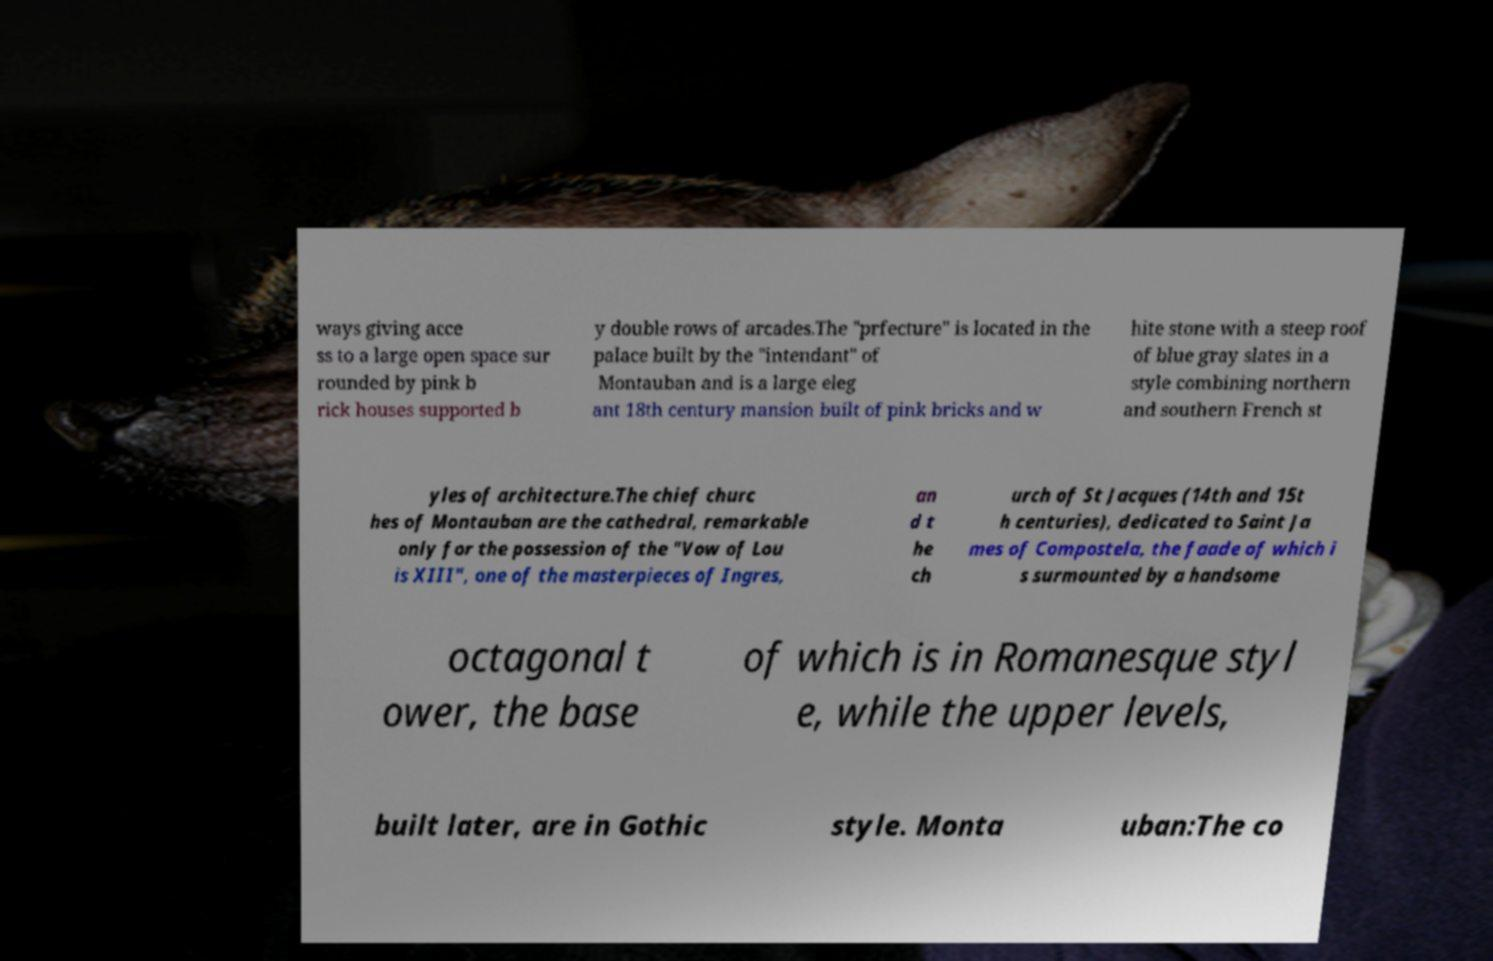I need the written content from this picture converted into text. Can you do that? ways giving acce ss to a large open space sur rounded by pink b rick houses supported b y double rows of arcades.The "prfecture" is located in the palace built by the "intendant" of Montauban and is a large eleg ant 18th century mansion built of pink bricks and w hite stone with a steep roof of blue gray slates in a style combining northern and southern French st yles of architecture.The chief churc hes of Montauban are the cathedral, remarkable only for the possession of the "Vow of Lou is XIII", one of the masterpieces of Ingres, an d t he ch urch of St Jacques (14th and 15t h centuries), dedicated to Saint Ja mes of Compostela, the faade of which i s surmounted by a handsome octagonal t ower, the base of which is in Romanesque styl e, while the upper levels, built later, are in Gothic style. Monta uban:The co 